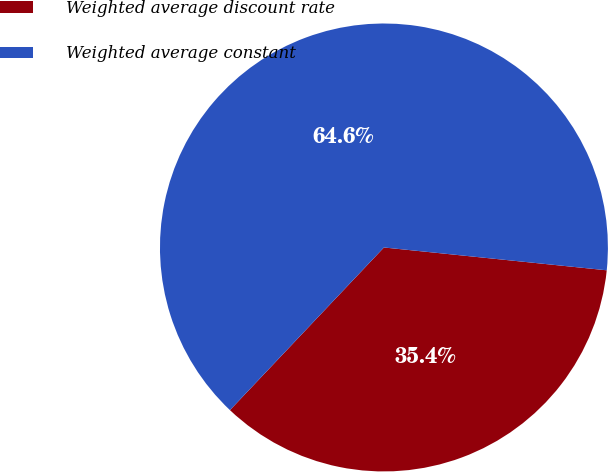Convert chart. <chart><loc_0><loc_0><loc_500><loc_500><pie_chart><fcel>Weighted average discount rate<fcel>Weighted average constant<nl><fcel>35.44%<fcel>64.56%<nl></chart> 